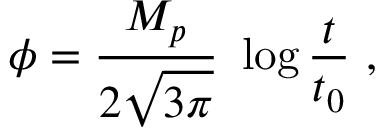<formula> <loc_0><loc_0><loc_500><loc_500>\phi = { \frac { M _ { p } } { 2 \sqrt { 3 \pi } } } \log { \frac { t } { t _ { 0 } } } \ ,</formula> 